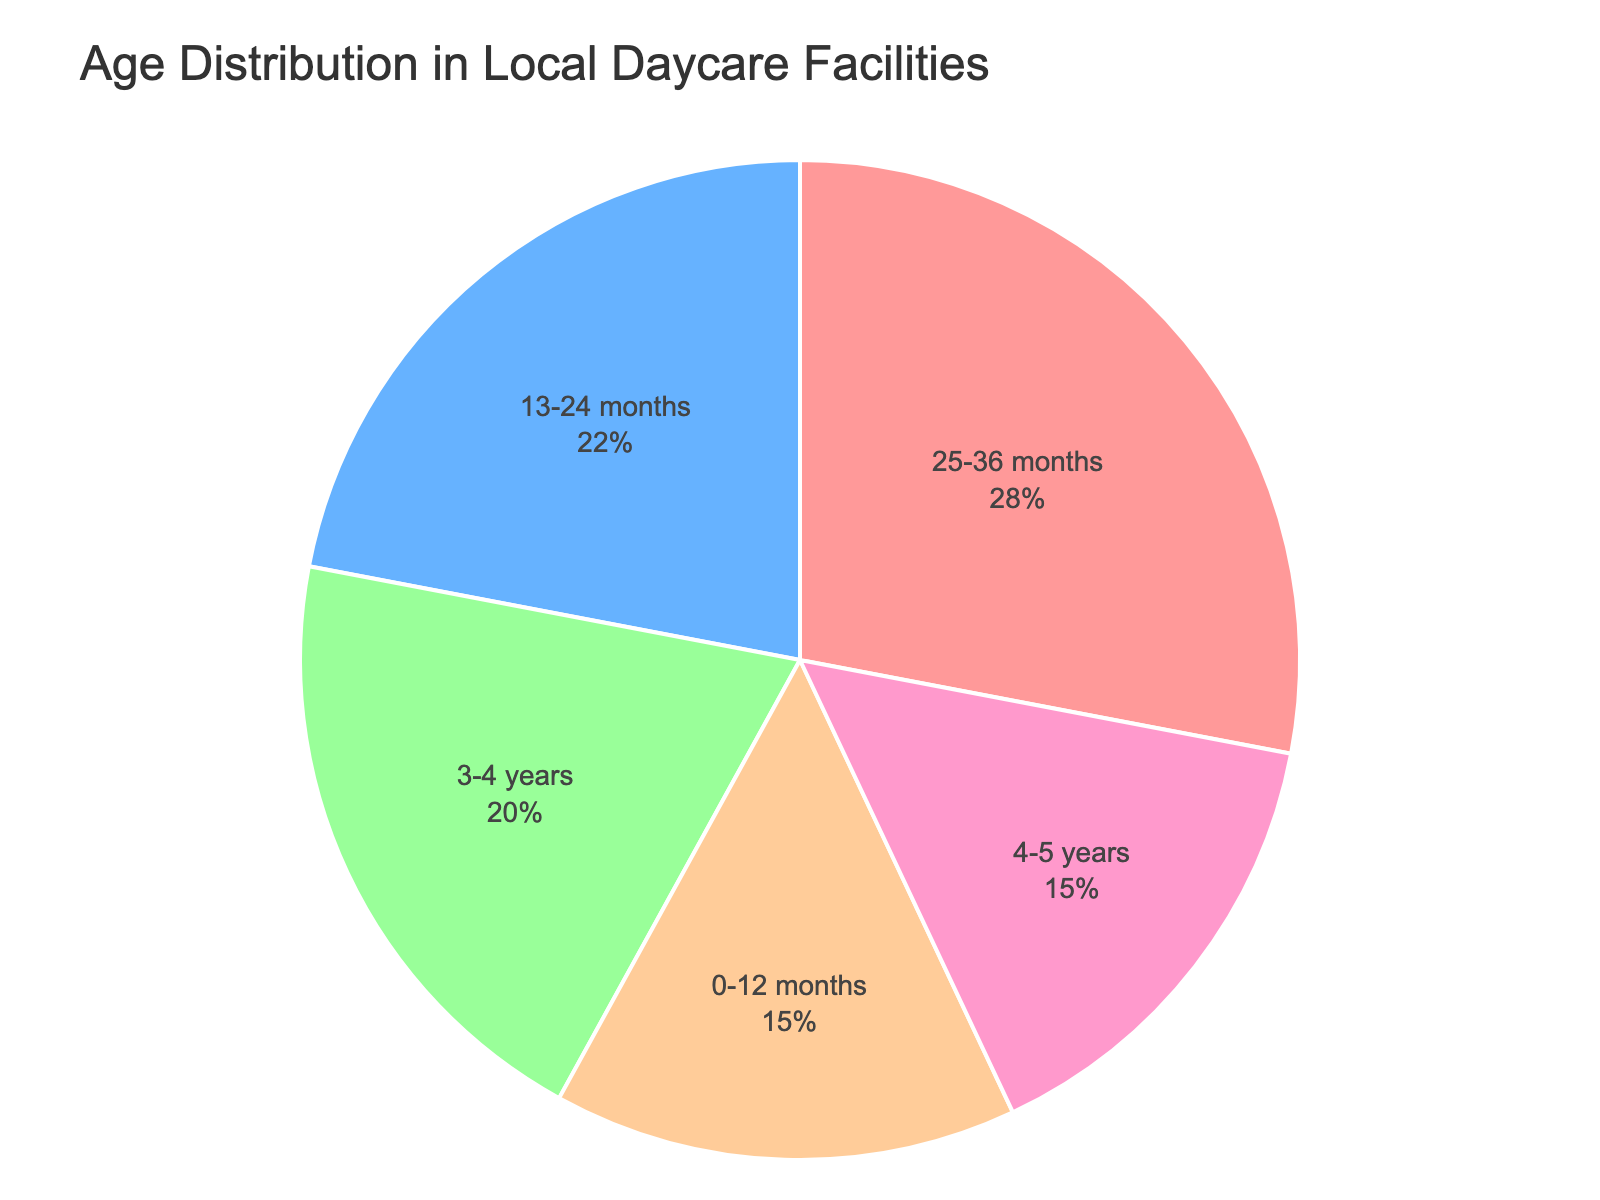What percentage of children enrolled are between 25-36 months old? To find the answer, look at the section of the pie chart labeled "25-36 months." The percentage should be displayed inside this section.
Answer: 28% Which age group has the smallest percentage of children enrolled? To determine this, compare the percentages of all the age groups. The smallest percentage value indicates the group with the least enrollment.
Answer: 0-12 months and 4-5 years What is the combined percentage of children enrolled in the 0-12 months and 4-5 years age groups? Add the percentages for the 0-12 months and 4-5 years groups: 15% + 15%.
Answer: 30% How does the enrollment percentage of the 3-4 years age group compare to that of the 13-24 months age group? Compare the percentages for the 3-4 years (20%) and 13-24 months (22%) age groups. The 13-24 months group has a higher enrollment percentage.
Answer: 13-24 months has a higher percentage Which two age groups together make up exactly 50% of the total enrollment? Look for any two age groups whose combined percentages equal 50%. Here, the 0-12 months (15%) and 3-4 years (20%) and 4-5 years groups combined make 20% + 15% + 15% = 50%.
Answer: 3-4 years and 4-5 years Is the enrollment percentage for the 25-36 months age group greater than, less than, or equal to the combined percentage of the 0-12 months and 4-5 years age groups? Find the sum of the percentages for 0-12 months (15%) and 4-5 years (15%) which is 30%. Compare this total to the percentage for the 25-36 months group (28%).
Answer: Less than What is the average enrollment percentage across all age groups? To find the average, add all the percentages together and divide by the number of age groups: (15% + 22% + 28% + 20% + 15%) / 5 = 20%.
Answer: 20% Which color represents the 13-24 months age group in the pie chart? Identify the color associated with the "13-24 months" section by looking at the chart. Each age group is represented by a distinct color, and the 13-24 months group is likely labeled.
Answer: Blue How much greater is the percentage of 25-36 months children than the percentage of 4-5 years children? Subtract the percentage of the 4-5 years group from the 25-36 months group: 28% - 15% = 13%.
Answer: 13% What is the median age group percentage? Arrange the percentages in ascending order: 15%, 15%, 20%, 22%, 28%. The middle value is the median, which in this case is 20%.
Answer: 20% 